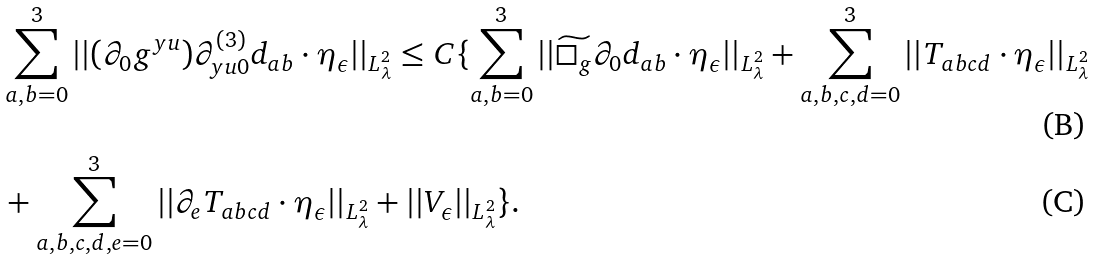<formula> <loc_0><loc_0><loc_500><loc_500>& \sum _ { a , b = 0 } ^ { 3 } | | ( \partial _ { 0 } g ^ { y u } ) \partial ^ { ( 3 ) } _ { y u 0 } d _ { a b } \cdot \eta _ { \epsilon } | | _ { L ^ { 2 } _ { \lambda } } \leq C \{ \sum _ { a , b = 0 } ^ { 3 } | | \widetilde { \Box _ { g } } \partial _ { 0 } d _ { a b } \cdot \eta _ { \epsilon } | | _ { L ^ { 2 } _ { \lambda } } + \sum _ { a , b , c , d = 0 } ^ { 3 } | | T _ { a b c d } \cdot \eta _ { \epsilon } | | _ { L ^ { 2 } _ { \lambda } } \\ & + \sum _ { a , b , c , d , e = 0 } ^ { 3 } | | \partial _ { e } T _ { a b c d } \cdot \eta _ { \epsilon } | | _ { L ^ { 2 } _ { \lambda } } + | | V _ { \epsilon } | | _ { L ^ { 2 } _ { \lambda } } \} .</formula> 